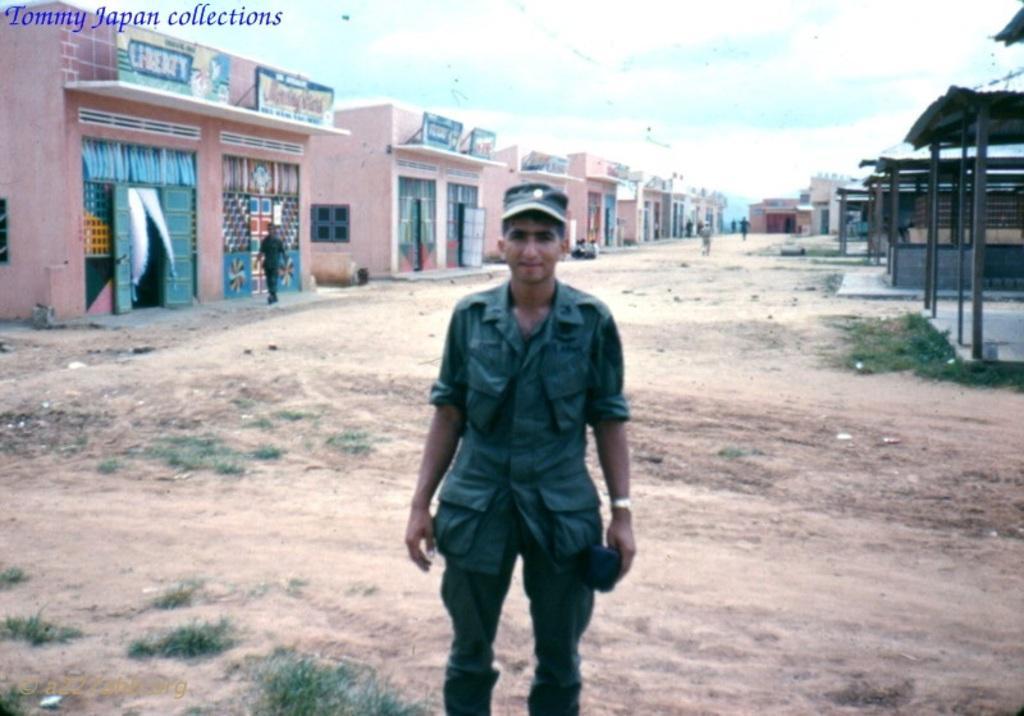Can you describe this image briefly? In this image there are people and we can see buildings. On the right there are sheds. At the bottom there is grass. In the background there is sky. 